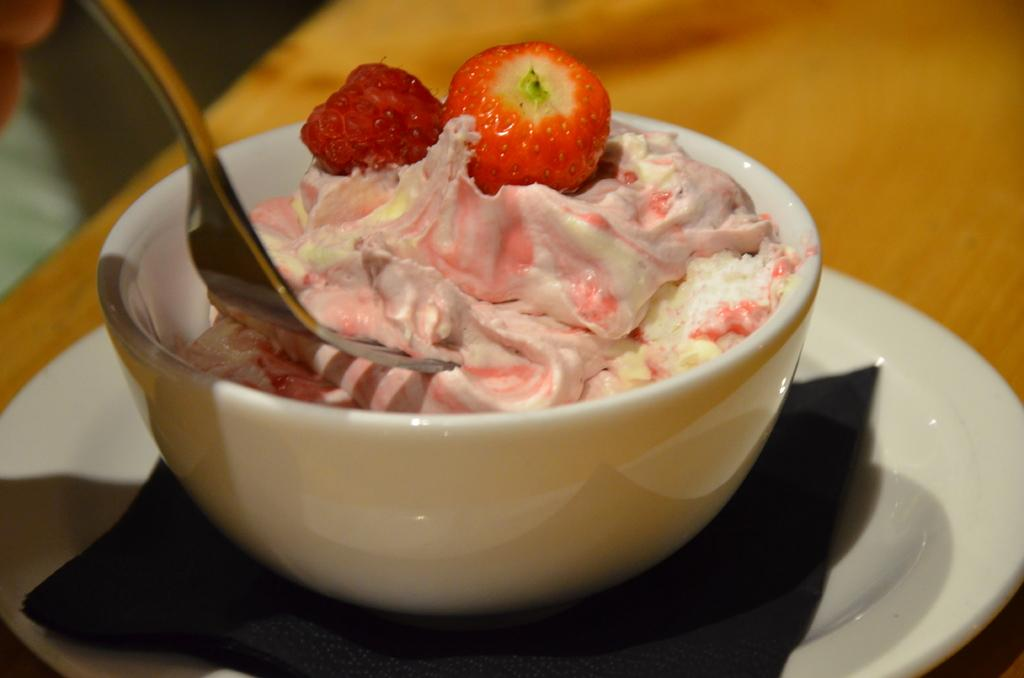What is present on the plate in the image? There are strawberries in the image. What is the material of the platform in the image? The platform is made of wood. What type of utensil can be seen in the image? There is a fork in the image. What is in the bowl in the image? There is food in a bowl in the image. What else is present in the image besides the plate, fork, and bowl? There is a cloth in the image. Where is the store located in the image? There is no store present in the image. What type of rod is used to hold the plate in the image? There is no rod present in the image; the plate is placed on a wooden platform. 